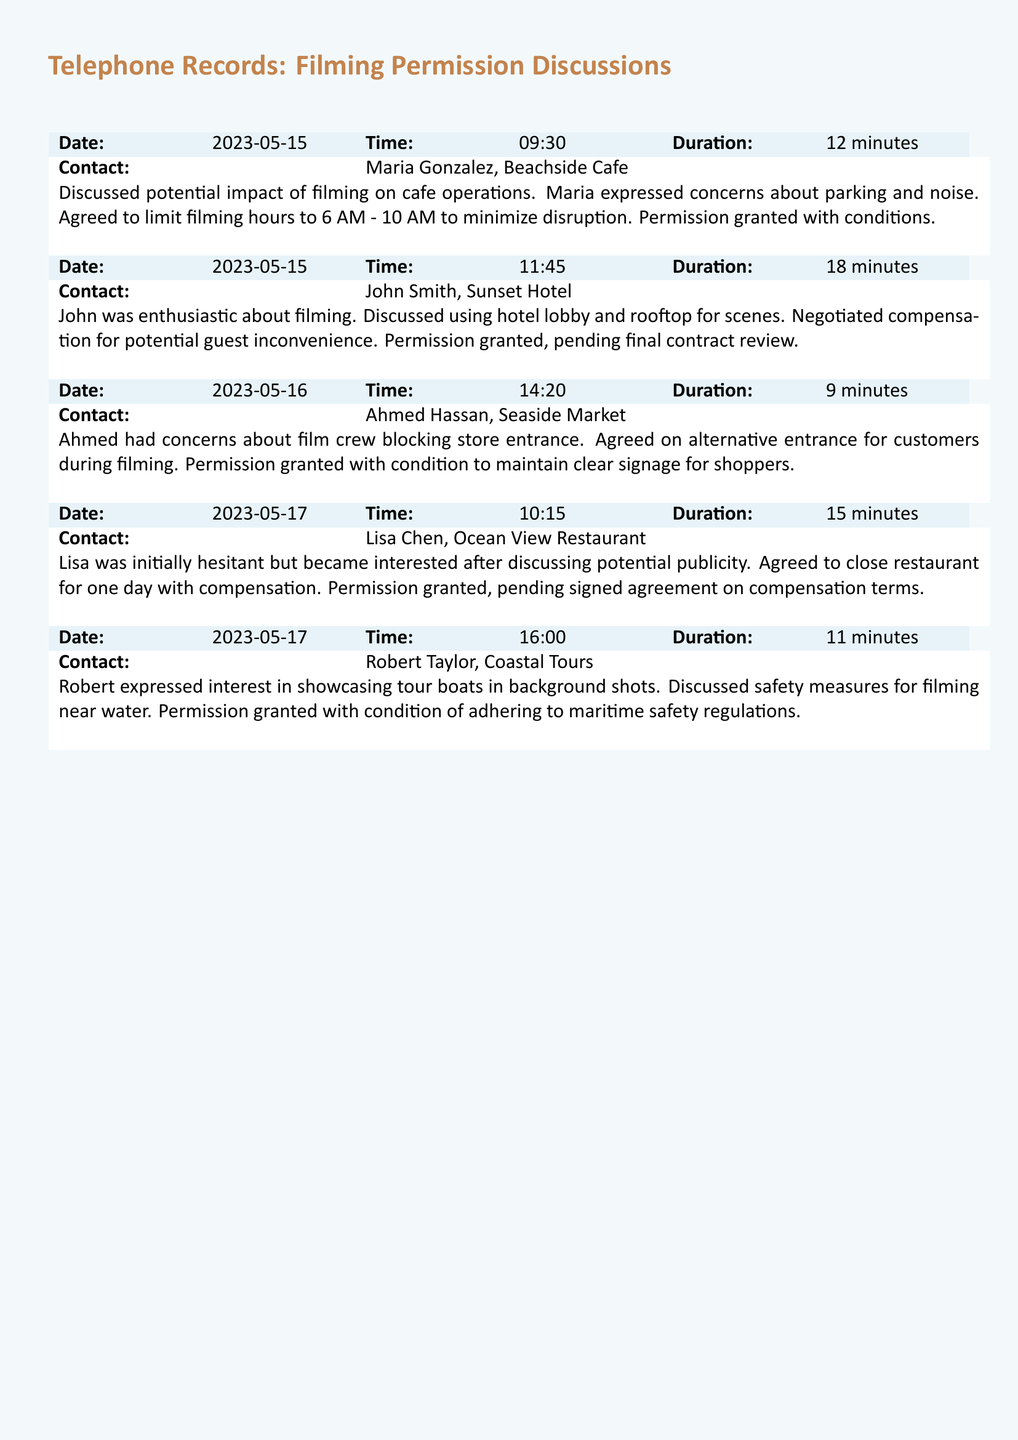What is the date of the first recorded phone call? The date of the first call is found in the record and is specifically noted as 2023-05-15.
Answer: 2023-05-15 Who did Maria Gonzalez represent? The record states that Maria Gonzalez is from Beachside Cafe, indicating her affiliation.
Answer: Beachside Cafe How long did the conversation with John Smith last? The duration of the conversation is explicitly mentioned as 18 minutes.
Answer: 18 minutes What condition was agreed upon for Ahmed Hassan regarding filming? The condition regarding the filming is noted as maintaining clear signage for shoppers.
Answer: Maintain clear signage for shoppers Which business owner was initially hesitant about filming? The document states that Lisa Chen was initially hesitant but later became interested.
Answer: Lisa Chen What time range was agreed upon to limit filming at Beachside Cafe? The specifics of the filming hours are indicated to be from 6 AM to 10 AM.
Answer: 6 AM - 10 AM What was Robert Taylor interested in showcasing during the filming? The document mentions that Robert expressed interest in showcasing tour boats in background shots.
Answer: Tour boats What was discussed as a safety measure for Robert's filming? The record specifically states the need to adhere to maritime safety regulations for filming near water.
Answer: Maritime safety regulations 